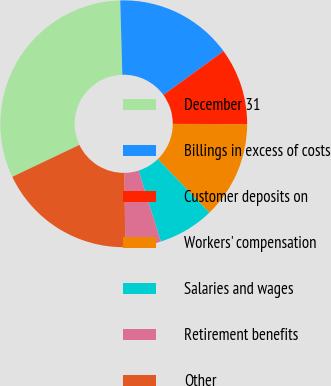<chart> <loc_0><loc_0><loc_500><loc_500><pie_chart><fcel>December 31<fcel>Billings in excess of costs<fcel>Customer deposits on<fcel>Workers' compensation<fcel>Salaries and wages<fcel>Retirement benefits<fcel>Other<nl><fcel>31.62%<fcel>15.44%<fcel>10.05%<fcel>12.75%<fcel>7.35%<fcel>4.66%<fcel>18.14%<nl></chart> 